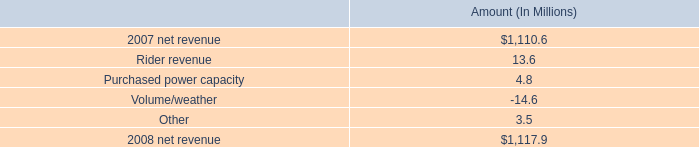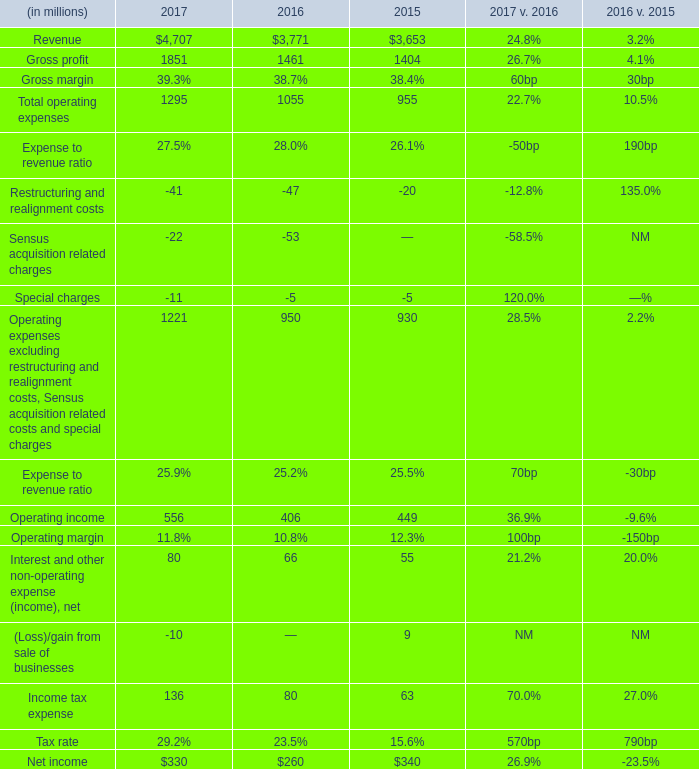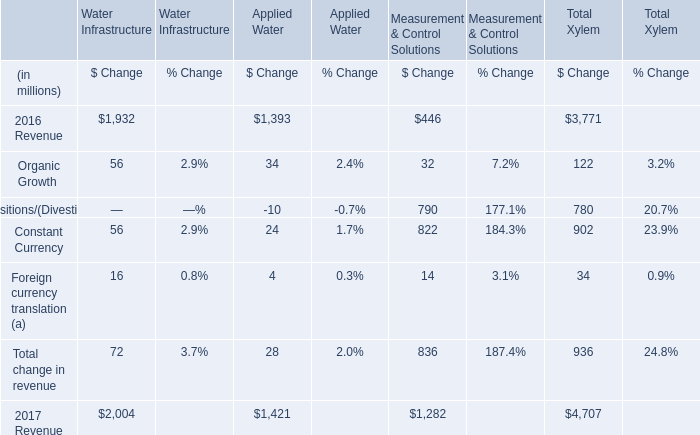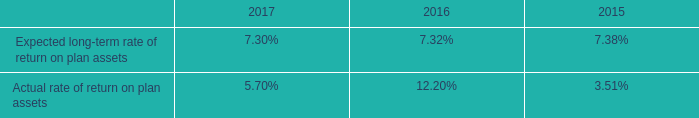In the year with lowest amount of Operating income, what's the increasing rate of Income tax expense? (in %) 
Computations: ((136 - 80) / 80)
Answer: 0.7. 